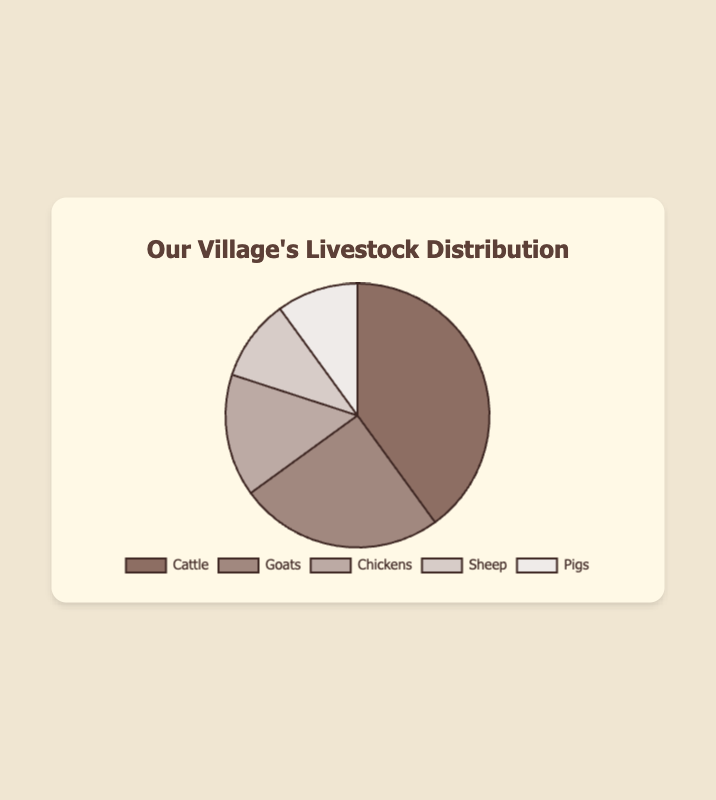What is the most common type of livestock in the village? The most common type of livestock is the one with the highest percentage. According to the chart, Cattle have the largest percentage at 40%.
Answer: Cattle Which two types of livestock have the same percentage share? By looking at the chart, we can see that both Sheep and Pigs have equal percentages of 10%.
Answer: Sheep and Pigs How much greater is the percentage of Cattle compared to Goats? First, find the percentage for Cattle (40%) and for Goats (25%). The difference is 40% - 25% = 15%.
Answer: 15% What is the combined percentage of Chickens and Sheep? To find the combined percentage, sum the percentages of Chickens (15%) and Sheep (10%). The total is 15% + 10% = 25%.
Answer: 25% If you exclude Cattle, what percentage of the livestock does the remaining types represent? Subtract the percentage of Cattle from 100%, that is, 100% - 40% = 60%.
Answer: 60% Among Goats, Chickens, Sheep, and Pigs, which type of livestock is the next most common after Cattle? According to the chart, after Cattle, the livestock with the next highest percentage is Goats at 25%.
Answer: Goats What is the total percentage of livestock types that individually have 10% each? Add the percentages of Sheep and Pigs which both have 10% each. Therefore, 10% + 10% = 20%.
Answer: 20% Which type of livestock has the lowest percentage share, and what is it? The chart shows that both Sheep and Pigs have the lowest percentage of 10%.
Answer: Sheep and Pigs If the total number of livestock is 200, how many of them are Goats? Given that Goats make up 25%, calculate the number of Goats: 200 * 0.25 = 50.
Answer: 50 